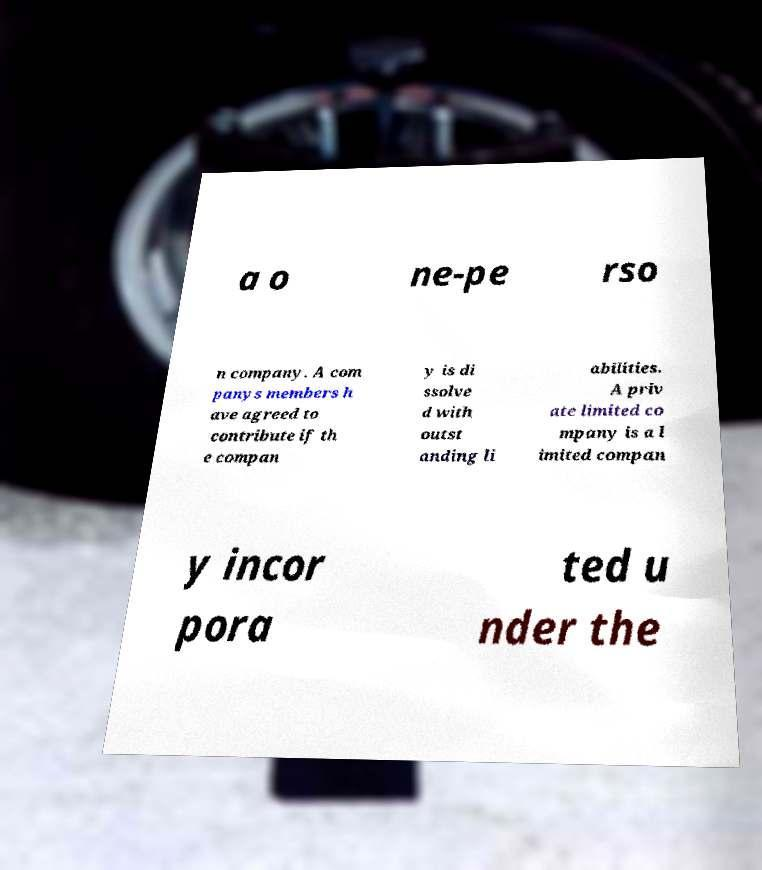Can you read and provide the text displayed in the image?This photo seems to have some interesting text. Can you extract and type it out for me? a o ne-pe rso n company. A com panys members h ave agreed to contribute if th e compan y is di ssolve d with outst anding li abilities. A priv ate limited co mpany is a l imited compan y incor pora ted u nder the 